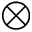<formula> <loc_0><loc_0><loc_500><loc_500>\otimes</formula> 